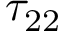Convert formula to latex. <formula><loc_0><loc_0><loc_500><loc_500>\tau _ { 2 2 }</formula> 